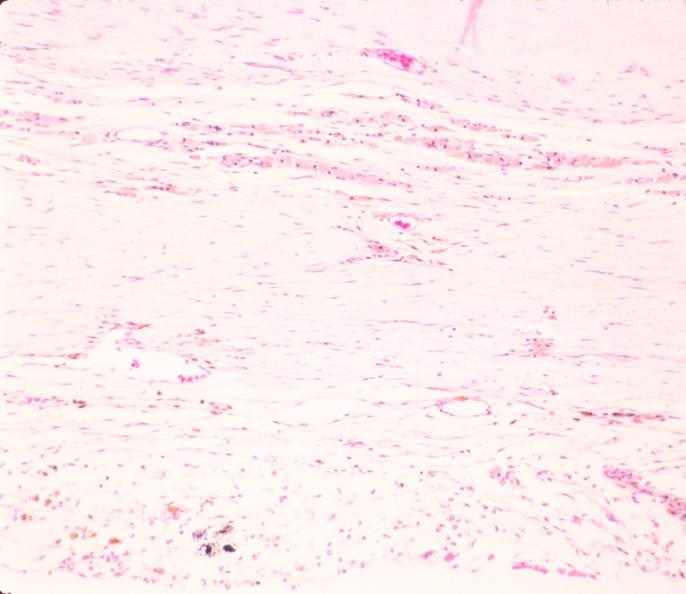s nervous present?
Answer the question using a single word or phrase. Yes 